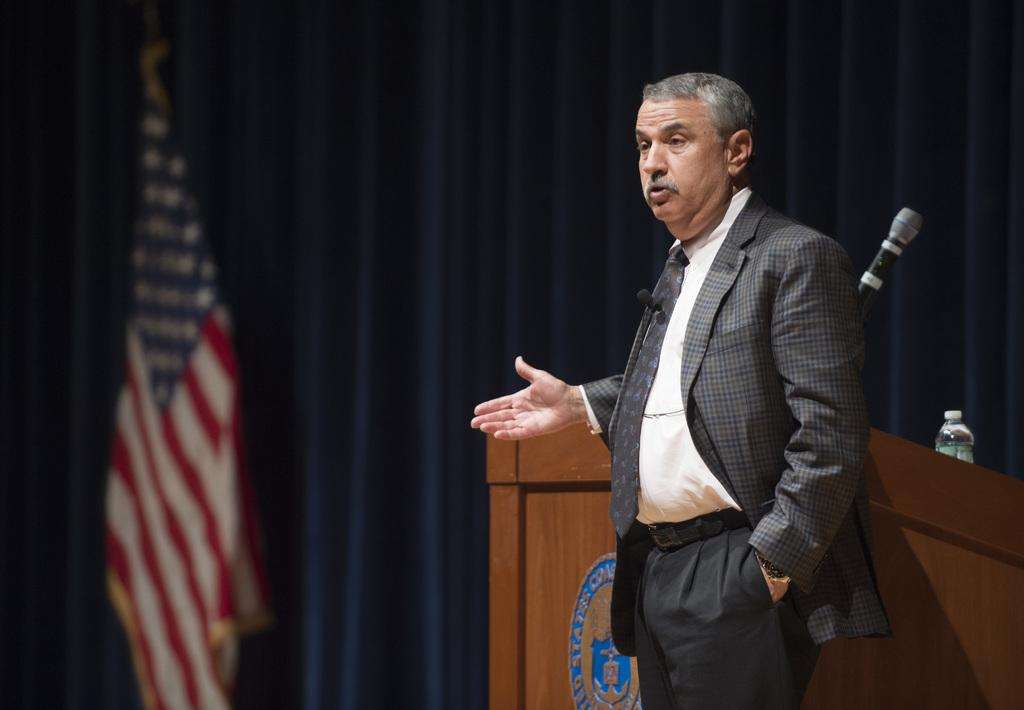What is the man in the image doing? There is a man standing in the image, but his specific activity is not clear. What can be seen on the podium in the image? There is a microphone and a water bottle on the podium. What is present in the image that represents a country or organization? There is a flag in the image. What can be seen in the background of the image? There are curtains in the background of the image. What type of winter clothing is the goat wearing in the image? There is no goat present in the image, and therefore no winter clothing can be observed. 